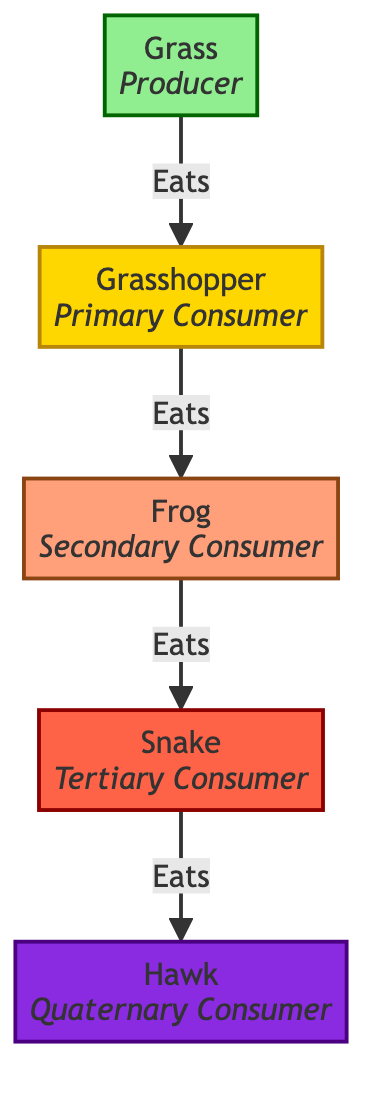What is the primary producer in this food chain? The diagram lists "Grass" as the first node, which is labeled as the producer. This indicates that it is the primary source of energy in this food chain.
Answer: Grass How many trophic levels are represented in this food chain? There are five distinct nodes representing different trophic levels: Producer, Primary Consumer, Secondary Consumer, Tertiary Consumer, and Quaternary Consumer. Counting these gives a total of five levels.
Answer: 5 Which consumer directly eats the Grasshopper? The arrow from the node "Grasshopper" points to the "Frog" node, indicating that the frog is the next level consumer that eats the grasshopper.
Answer: Frog What type of consumer is the Snake? The node labeled "Snake" is identified as a Tertiary Consumer in the diagram. This classification comes from its position in the flow and the labels associated with it.
Answer: Tertiary Consumer What is the flow direction from Grass to Hawk? The flow progresses sequentially through the nodes: Grass to Grasshopper, then to Frog, followed by Snake, and finally to Hawk. This shows a linear feeding relationship from producer to quaternary consumer, indicating energy transfer through the food chain.
Answer: From Grass to Hawk is Grass, Grasshopper, Frog, Snake How many consumers are in this food chain? Looking at the diagram, we can see there are four consumer nodes: Grasshopper, Frog, Snake, and Hawk. Counting these nodes gives the total number of consumers present.
Answer: 4 Which consumer is at the highest trophic level? The diagram positions the "Hawk" at the topmost level, labeled as the Quaternary Consumer, making it the highest trophic level in this food chain.
Answer: Hawk What does the arrow between nodes represent in this diagram? The arrows in the diagram indicate feeding relationships, showing which organism consumes the other. Each arrow is a representation of the direction of energy flow, illustrating who eats whom.
Answer: Feeding relationships How many edges (arrows) are in this diagram? There are four arrows connecting the five nodes: Grass to Grasshopper, Grasshopper to Frog, Frog to Snake, and Snake to Hawk. Counting these connections gives us the total number of edges in the diagram.
Answer: 4 